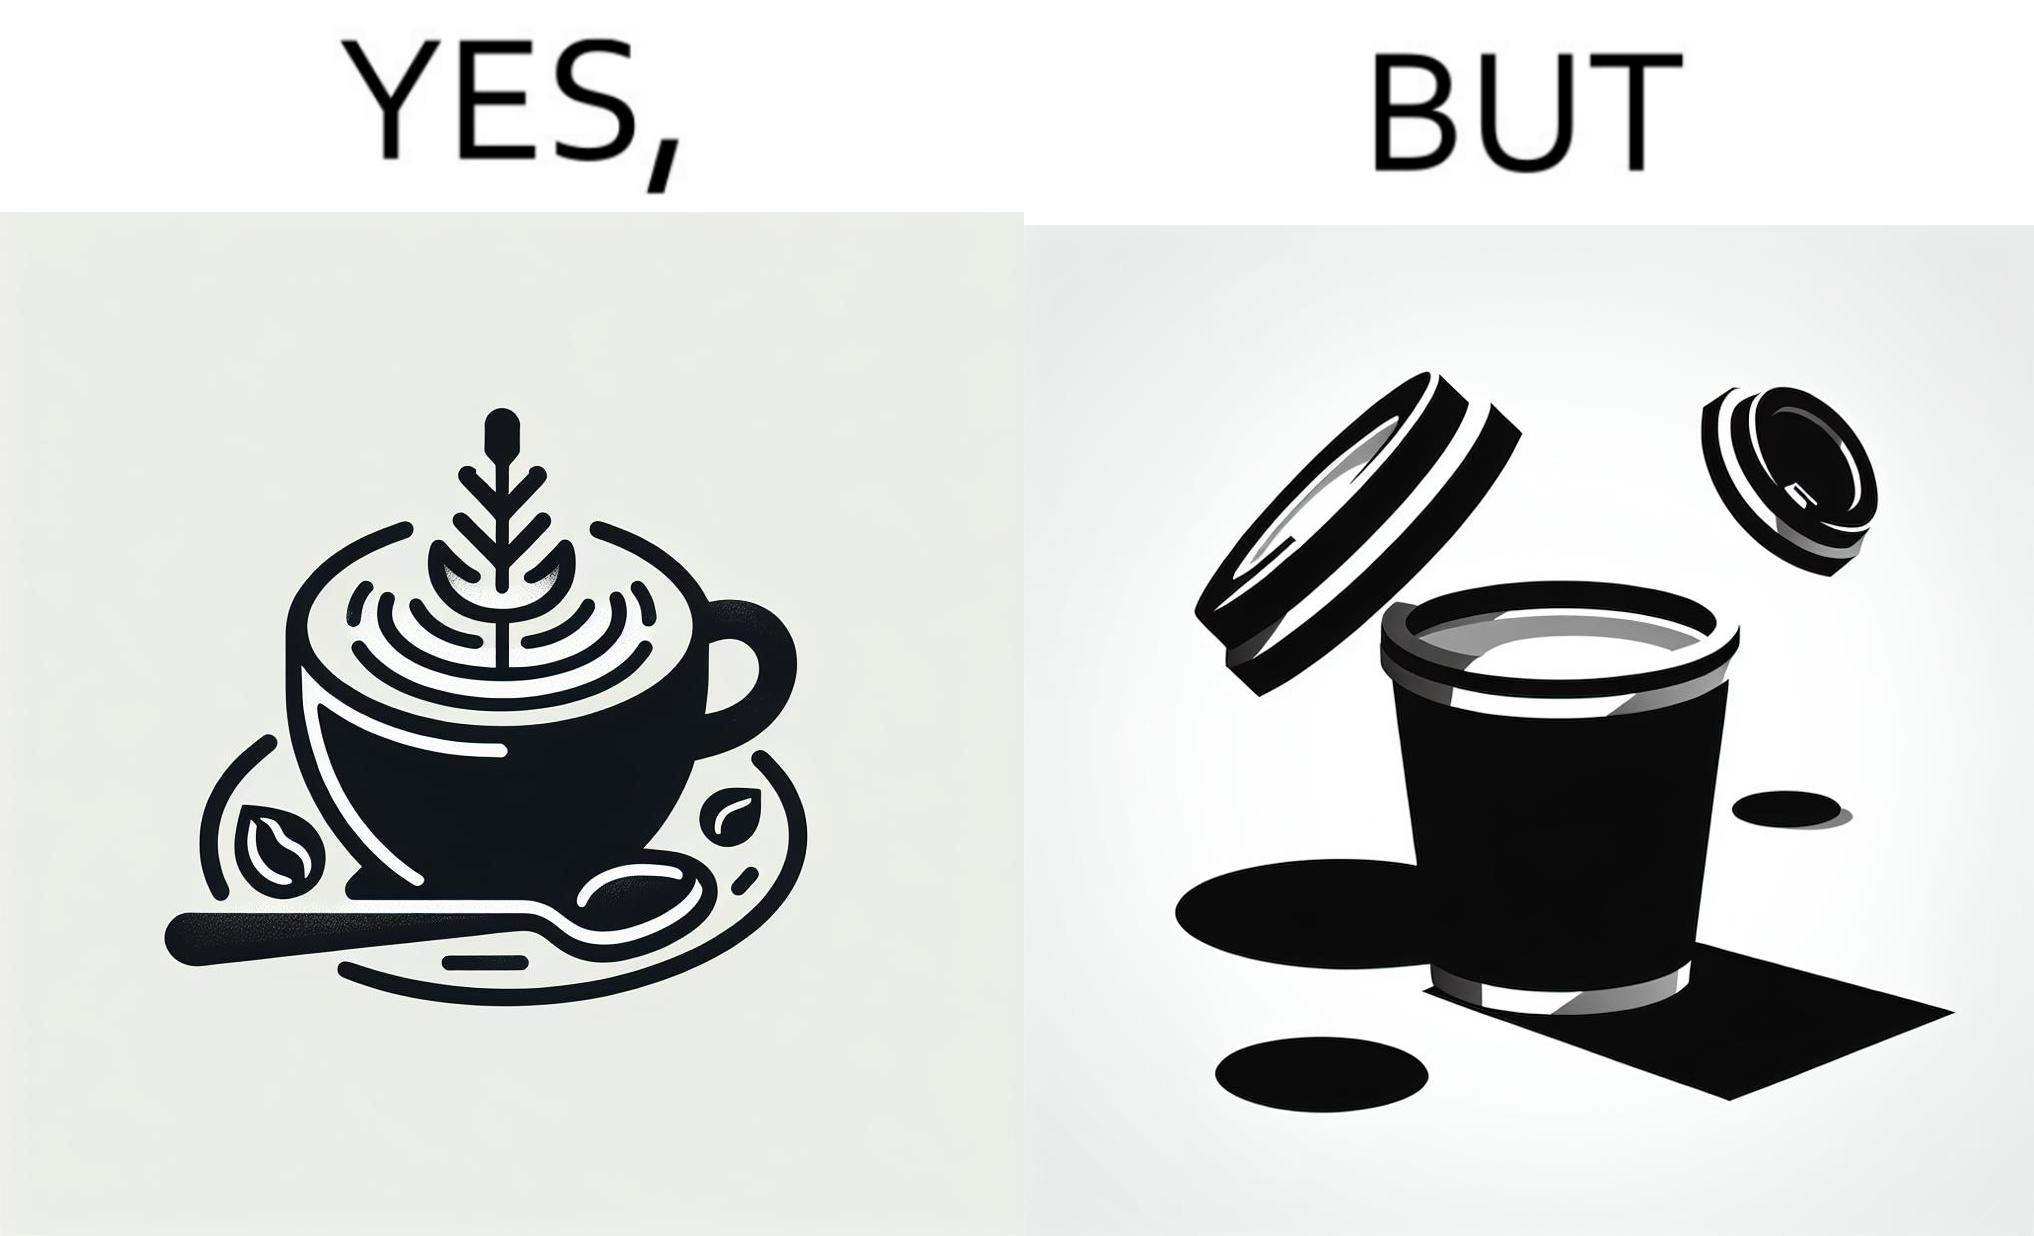Is this a satirical image? Yes, this image is satirical. 